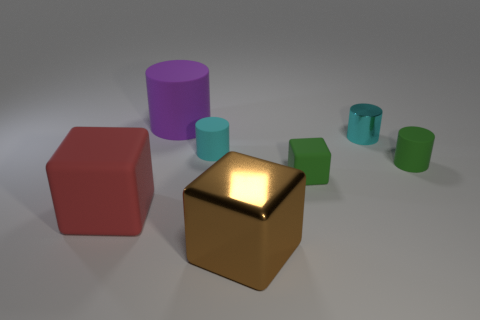If these objects had a real-world size, how big do you think they would be? Judging by the proportions and assuming these are common objects, the big purple cylinder could be akin to a large mug or container, approximately 20cm tall. The tiny cube might then be roughly 5cm on each side, similar in size to a standard dice or a small jewelry box. Could these objects serve a functional purpose in a real-world setting? Absolutely! The cylinders and cubes could be containers, decorative elements, or parts of a larger contraption. Their simple shapes are versatile, making the potential uses quite broad depending on their material properties and scale. 